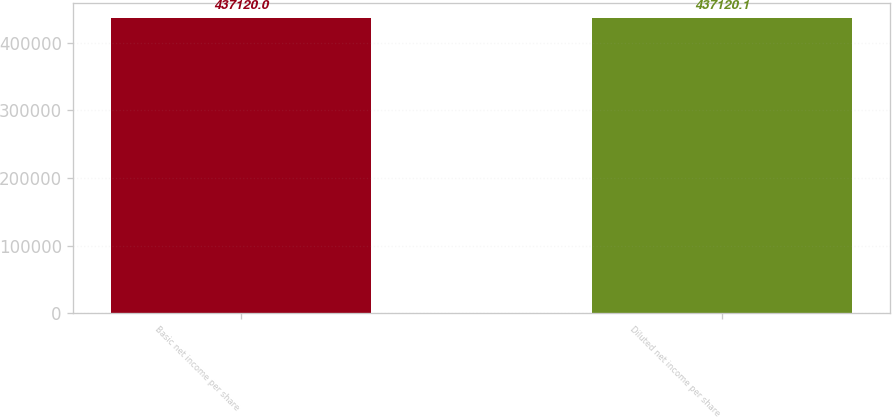<chart> <loc_0><loc_0><loc_500><loc_500><bar_chart><fcel>Basic net income per share<fcel>Diluted net income per share<nl><fcel>437120<fcel>437120<nl></chart> 